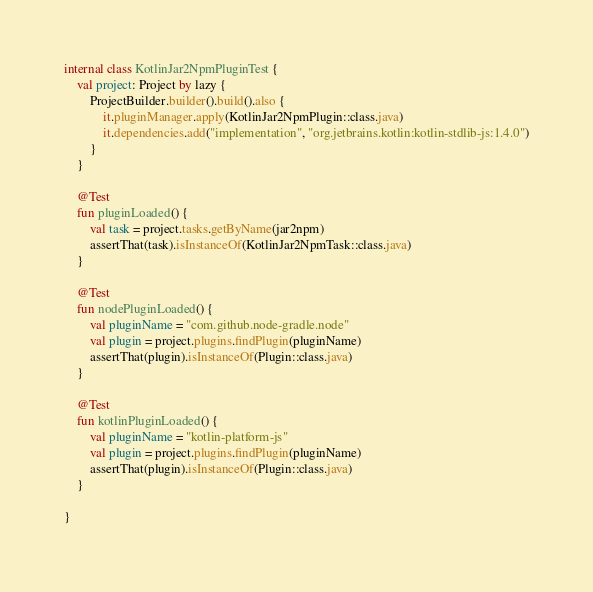Convert code to text. <code><loc_0><loc_0><loc_500><loc_500><_Kotlin_>
internal class KotlinJar2NpmPluginTest {
    val project: Project by lazy {
        ProjectBuilder.builder().build().also {
            it.pluginManager.apply(KotlinJar2NpmPlugin::class.java)
            it.dependencies.add("implementation", "org.jetbrains.kotlin:kotlin-stdlib-js:1.4.0")
        }
    }

    @Test
    fun pluginLoaded() {
        val task = project.tasks.getByName(jar2npm)
        assertThat(task).isInstanceOf(KotlinJar2NpmTask::class.java)
    }

    @Test
    fun nodePluginLoaded() {
        val pluginName = "com.github.node-gradle.node"
        val plugin = project.plugins.findPlugin(pluginName)
        assertThat(plugin).isInstanceOf(Plugin::class.java)
    }

    @Test
    fun kotlinPluginLoaded() {
        val pluginName = "kotlin-platform-js"
        val plugin = project.plugins.findPlugin(pluginName)
        assertThat(plugin).isInstanceOf(Plugin::class.java)
    }

}
</code> 